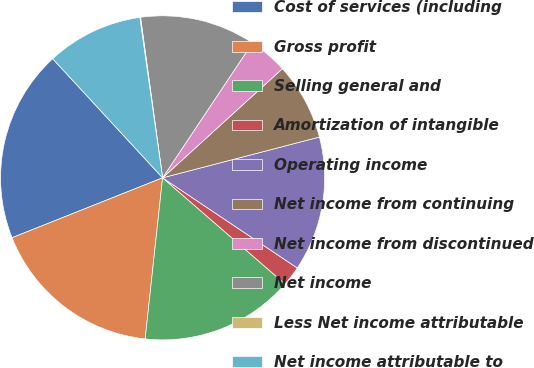Convert chart to OTSL. <chart><loc_0><loc_0><loc_500><loc_500><pie_chart><fcel>Cost of services (including<fcel>Gross profit<fcel>Selling general and<fcel>Amortization of intangible<fcel>Operating income<fcel>Net income from continuing<fcel>Net income from discontinued<fcel>Net income<fcel>Less Net income attributable<fcel>Net income attributable to<nl><fcel>19.17%<fcel>17.26%<fcel>15.35%<fcel>1.98%<fcel>13.44%<fcel>7.71%<fcel>3.89%<fcel>11.53%<fcel>0.07%<fcel>9.62%<nl></chart> 